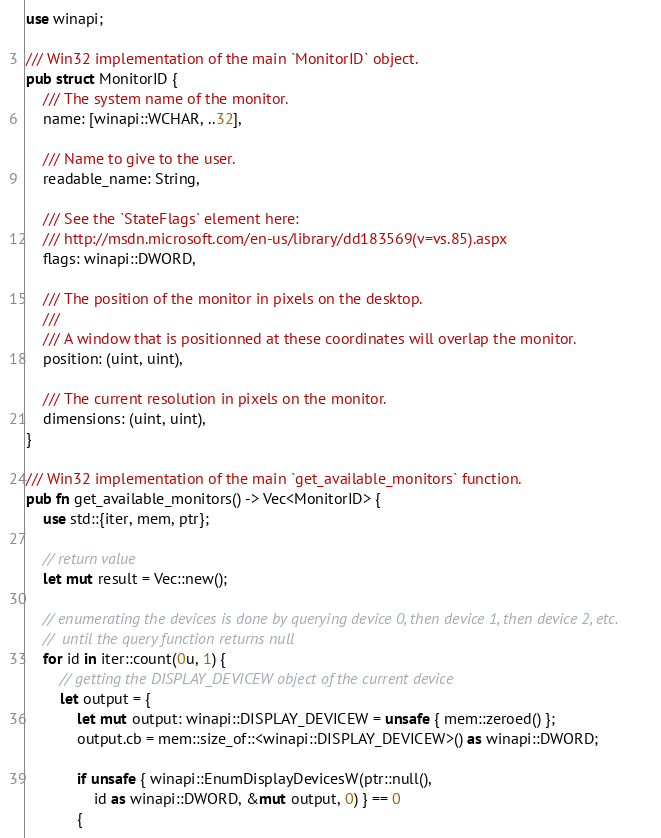<code> <loc_0><loc_0><loc_500><loc_500><_Rust_>use winapi;

/// Win32 implementation of the main `MonitorID` object.
pub struct MonitorID {
    /// The system name of the monitor.
    name: [winapi::WCHAR, ..32],

    /// Name to give to the user.
    readable_name: String,

    /// See the `StateFlags` element here:
    /// http://msdn.microsoft.com/en-us/library/dd183569(v=vs.85).aspx
    flags: winapi::DWORD,

    /// The position of the monitor in pixels on the desktop.
    ///
    /// A window that is positionned at these coordinates will overlap the monitor.
    position: (uint, uint),

    /// The current resolution in pixels on the monitor.
    dimensions: (uint, uint),
}

/// Win32 implementation of the main `get_available_monitors` function.
pub fn get_available_monitors() -> Vec<MonitorID> {
    use std::{iter, mem, ptr};

    // return value
    let mut result = Vec::new();

    // enumerating the devices is done by querying device 0, then device 1, then device 2, etc.
    //  until the query function returns null
    for id in iter::count(0u, 1) {
        // getting the DISPLAY_DEVICEW object of the current device
        let output = {
            let mut output: winapi::DISPLAY_DEVICEW = unsafe { mem::zeroed() };
            output.cb = mem::size_of::<winapi::DISPLAY_DEVICEW>() as winapi::DWORD;

            if unsafe { winapi::EnumDisplayDevicesW(ptr::null(),
                id as winapi::DWORD, &mut output, 0) } == 0
            {</code> 